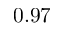<formula> <loc_0><loc_0><loc_500><loc_500>0 . 9 7</formula> 